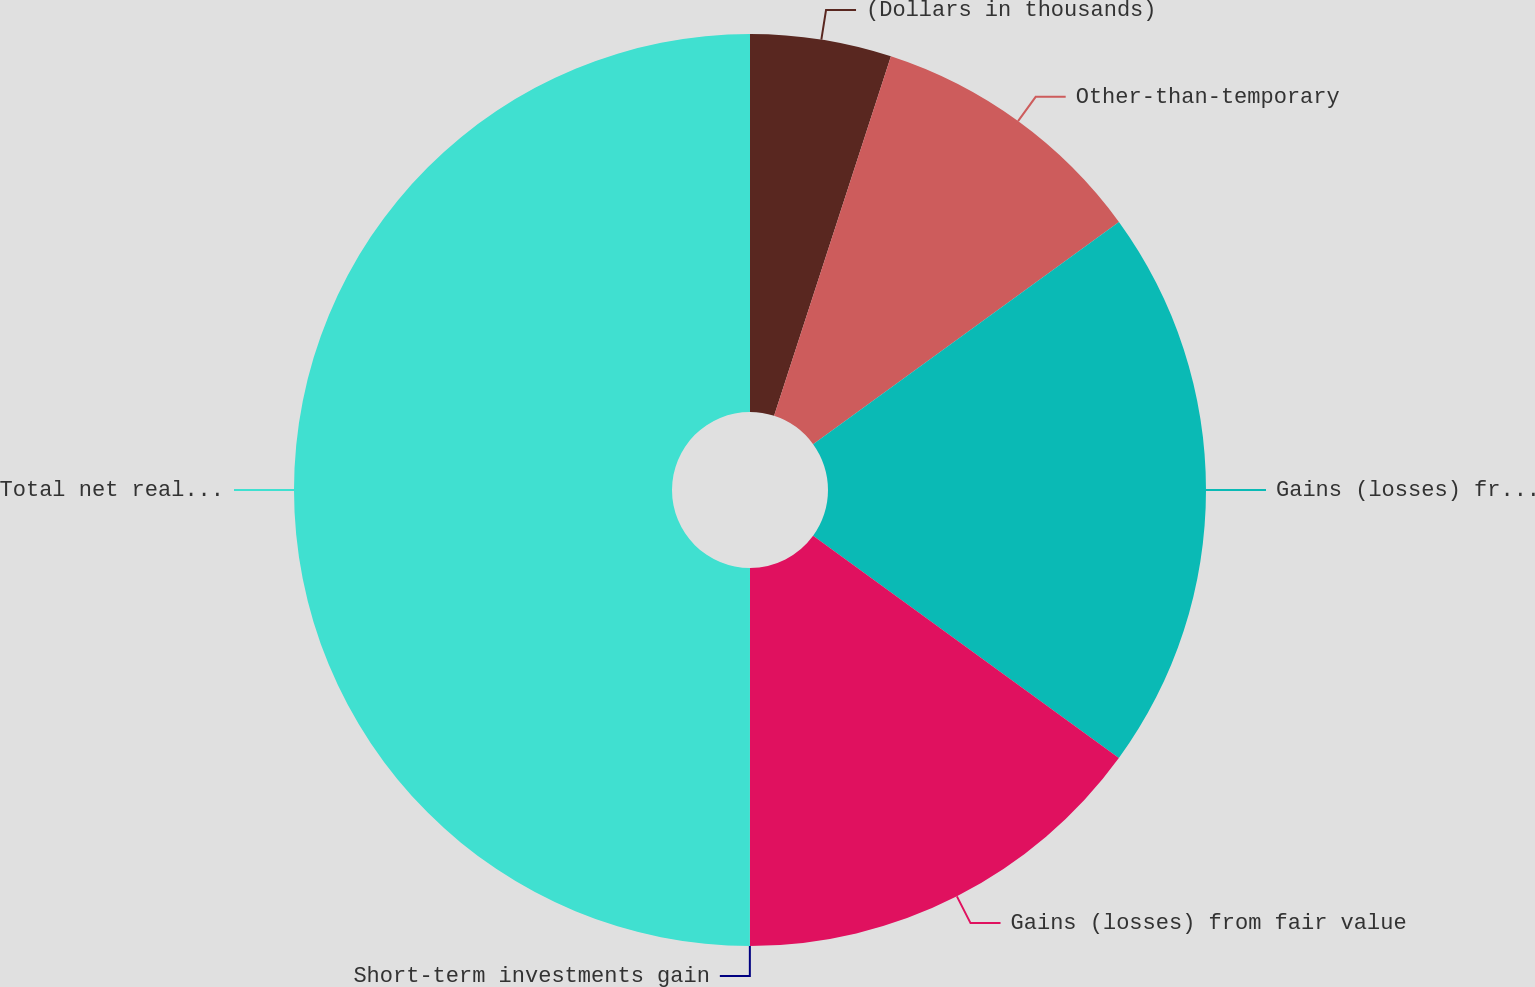Convert chart to OTSL. <chart><loc_0><loc_0><loc_500><loc_500><pie_chart><fcel>(Dollars in thousands)<fcel>Other-than-temporary<fcel>Gains (losses) from sales<fcel>Gains (losses) from fair value<fcel>Short-term investments gain<fcel>Total net realized capital<nl><fcel>5.0%<fcel>10.0%<fcel>20.0%<fcel>15.0%<fcel>0.0%<fcel>49.99%<nl></chart> 